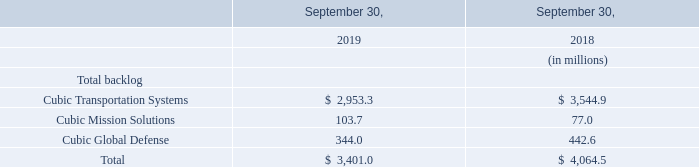Backlog
As reflected in the table above, total backlog decreased $663.5 million from September 30, 2018 to September 30, 2019. The decrease in backlog is primarily due to progression of work in 2019 on four large contracts awarded to CTS in fiscal 2018. In addition, we recorded a net decrease to backlog of $104.5 million on October 1, 2018 for the impact of the adoption of ASC 606. Changes in exchange rates between the prevailing currency in our foreign operations and the U.S. dollar as of September 30, 2019 decreased backlog by $79.7 million compared to September 30, 2018.
What is the change in total backlog in 2019? Decreased $663.5 million. What led to the decrease in backlog? Primarily due to progression of work in 2019 on four large contracts awarded to cts in fiscal 2018, impact of the adoption of asc 606. What are the segments under Total Backlog in the table? Cubic transportation systems, cubic mission solutions, cubic global defense. How many segments are there under Total Backlog? Cubic Transportation Systems##Cubic Mission Solutions##Cubic Global Defense
Answer: 3. What is the change in the backlog for Cubic Mission Solutions in 2019?
Answer scale should be: million. 103.7-77
Answer: 26.7. What is the percentage change in the backlog for Cubic Mission Solutions in 2019?
Answer scale should be: percent. (103.7-77)/77
Answer: 34.68. 